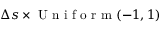Convert formula to latex. <formula><loc_0><loc_0><loc_500><loc_500>\Delta s \times U n i f o r m ( - 1 , 1 )</formula> 